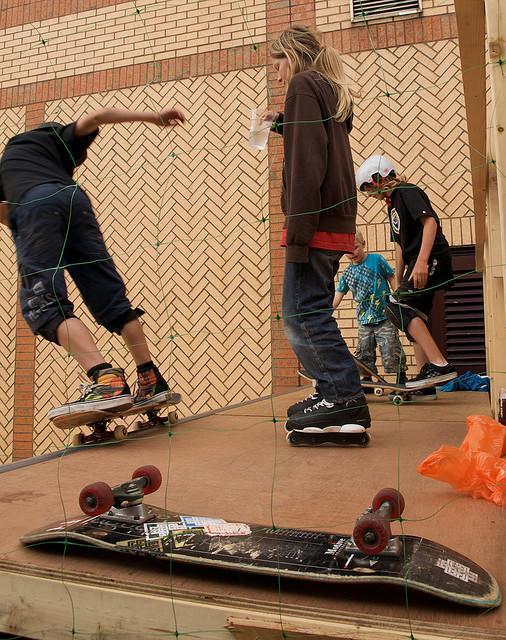How many people?
Give a very brief answer. 4. How many people are there?
Give a very brief answer. 4. How many skateboards can be seen?
Give a very brief answer. 2. 